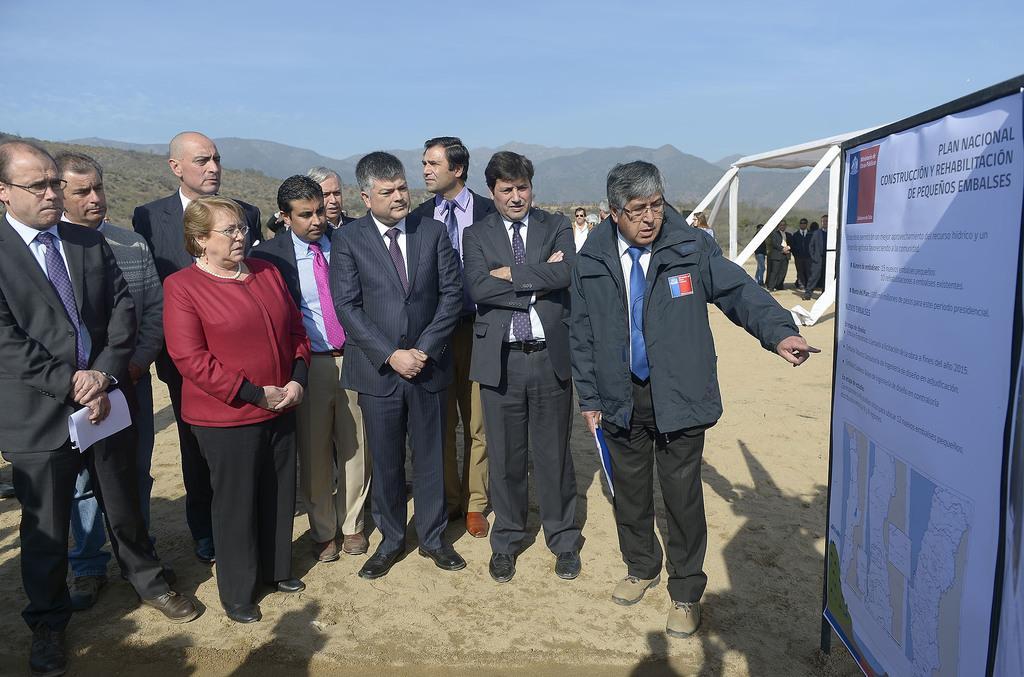In one or two sentences, can you explain what this image depicts? In this image we can see one women and men are standing. Men are wearing suits and woman is wearing red color jacket with black pant. Right side of the image one banner is there with some text and map. Background of the image mountains and persons are there. At the top of the image sky is there. 